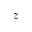<formula> <loc_0><loc_0><loc_500><loc_500>z</formula> 